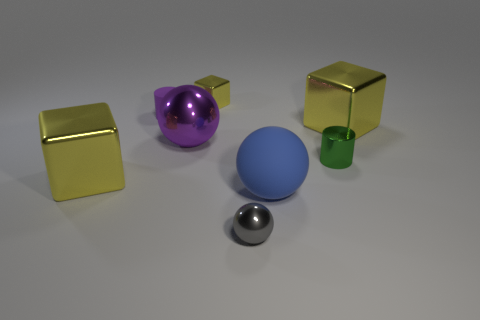Is there any other thing that has the same size as the purple cylinder?
Give a very brief answer. Yes. Is the size of the blue thing the same as the green cylinder in front of the large purple metal object?
Your response must be concise. No. The rubber object that is to the right of the tiny sphere has what shape?
Provide a short and direct response. Sphere. There is a shiny thing that is in front of the metal cube in front of the large purple metallic thing; what is its color?
Your answer should be compact. Gray. The other object that is the same shape as the small purple matte object is what color?
Your answer should be very brief. Green. How many metal cubes are the same color as the small shiny ball?
Your answer should be very brief. 0. Is the color of the matte ball the same as the thing that is to the right of the green thing?
Your answer should be very brief. No. What shape is the tiny object that is in front of the big purple metallic thing and left of the tiny green cylinder?
Make the answer very short. Sphere. What is the material of the big yellow cube that is left of the purple ball on the right side of the large yellow metal thing to the left of the small shiny sphere?
Your answer should be compact. Metal. Are there more gray spheres behind the gray sphere than large blue matte things right of the blue rubber ball?
Provide a short and direct response. No. 